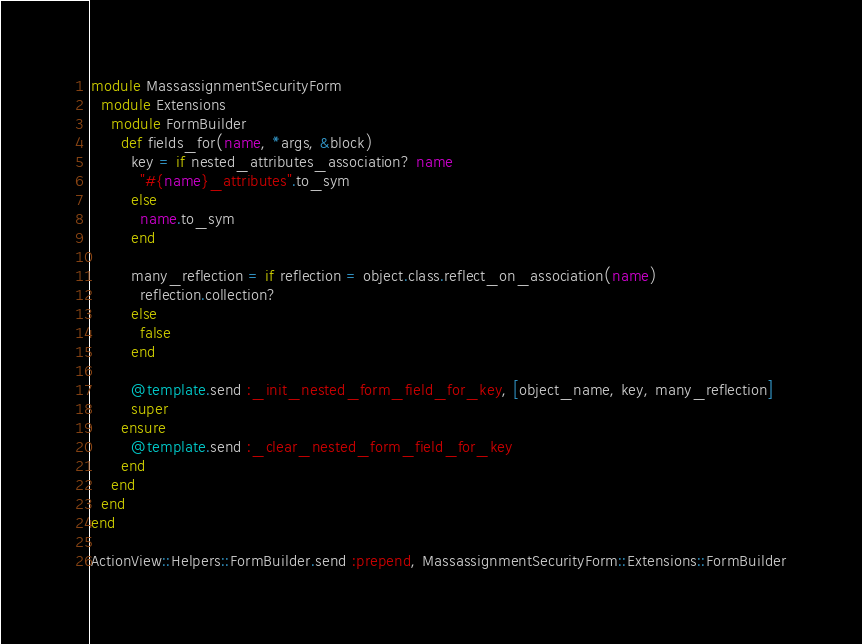Convert code to text. <code><loc_0><loc_0><loc_500><loc_500><_Ruby_>module MassassignmentSecurityForm
  module Extensions
    module FormBuilder
      def fields_for(name, *args, &block)
        key = if nested_attributes_association? name
          "#{name}_attributes".to_sym
        else
          name.to_sym
        end

        many_reflection = if reflection = object.class.reflect_on_association(name)
          reflection.collection?
        else
          false
        end
       
        @template.send :_init_nested_form_field_for_key, [object_name, key, many_reflection]
        super
      ensure
        @template.send :_clear_nested_form_field_for_key
      end
    end
  end
end

ActionView::Helpers::FormBuilder.send :prepend, MassassignmentSecurityForm::Extensions::FormBuilder
</code> 